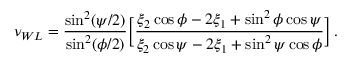Convert formula to latex. <formula><loc_0><loc_0><loc_500><loc_500>\nu _ { W L } = \frac { \sin ^ { 2 } ( \psi / 2 ) } { \sin ^ { 2 } ( \phi / 2 ) } \left [ \frac { \xi _ { 2 } \cos \phi - 2 \xi _ { 1 } + \sin ^ { 2 } \phi \cos \psi } { \xi _ { 2 } \cos \psi - 2 \xi _ { 1 } + \sin ^ { 2 } \psi \cos \phi } \right ] \, .</formula> 